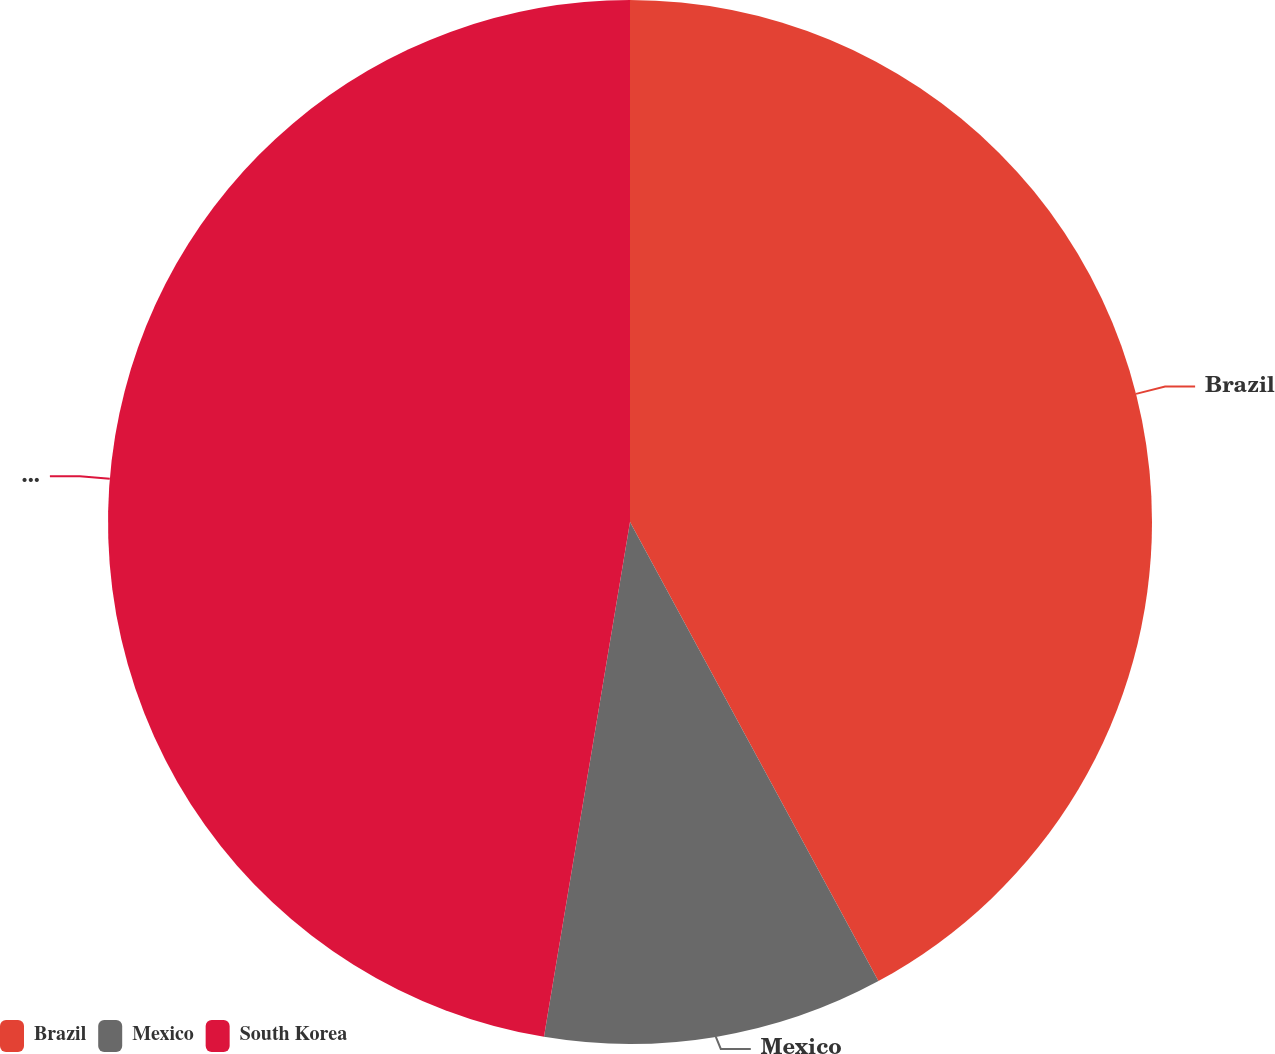Convert chart to OTSL. <chart><loc_0><loc_0><loc_500><loc_500><pie_chart><fcel>Brazil<fcel>Mexico<fcel>South Korea<nl><fcel>42.11%<fcel>10.53%<fcel>47.37%<nl></chart> 